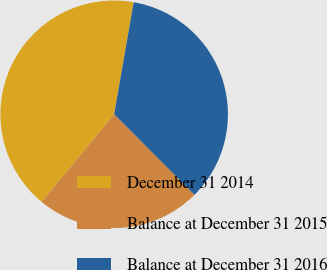Convert chart to OTSL. <chart><loc_0><loc_0><loc_500><loc_500><pie_chart><fcel>December 31 2014<fcel>Balance at December 31 2015<fcel>Balance at December 31 2016<nl><fcel>41.74%<fcel>23.48%<fcel>34.78%<nl></chart> 